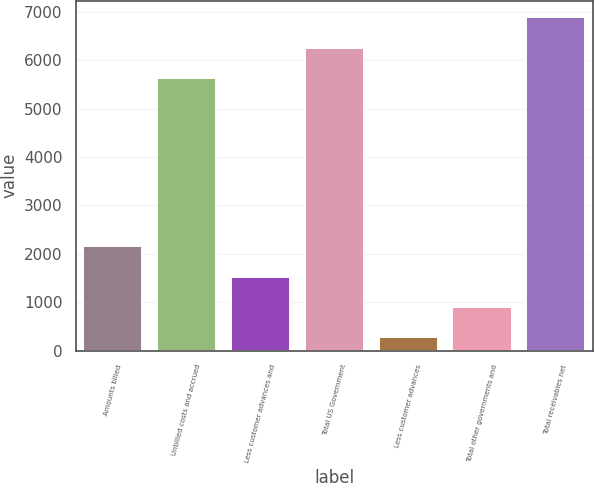Convert chart. <chart><loc_0><loc_0><loc_500><loc_500><bar_chart><fcel>Amounts billed<fcel>Unbilled costs and accrued<fcel>Less customer advances and<fcel>Total US Government<fcel>Less customer advances<fcel>Total other governments and<fcel>Total receivables net<nl><fcel>2159.3<fcel>5630<fcel>1530.2<fcel>6259.1<fcel>272<fcel>901.1<fcel>6888.2<nl></chart> 